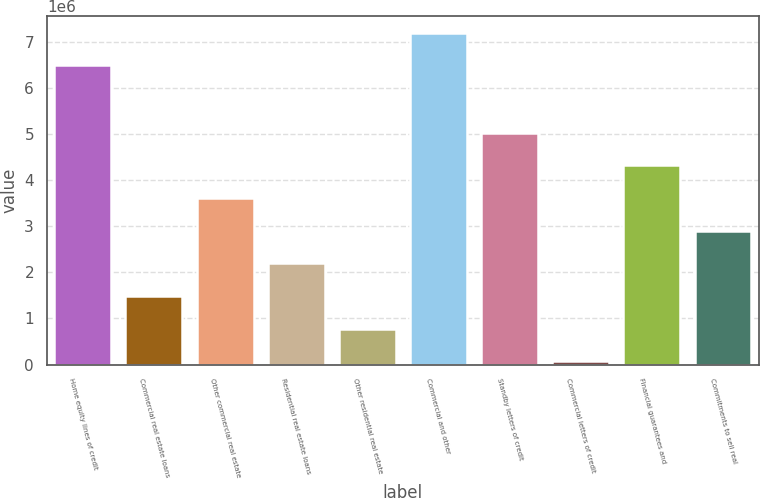<chart> <loc_0><loc_0><loc_500><loc_500><bar_chart><fcel>Home equity lines of credit<fcel>Commercial real estate loans<fcel>Other commercial real estate<fcel>Residential real estate loans<fcel>Other residential real estate<fcel>Commercial and other<fcel>Standby letters of credit<fcel>Commercial letters of credit<fcel>Financial guarantees and<fcel>Commitments to sell real<nl><fcel>6.48299e+06<fcel>1.48414e+06<fcel>3.61078e+06<fcel>2.19302e+06<fcel>775258<fcel>7.19187e+06<fcel>5.02854e+06<fcel>66377<fcel>4.31966e+06<fcel>2.9019e+06<nl></chart> 